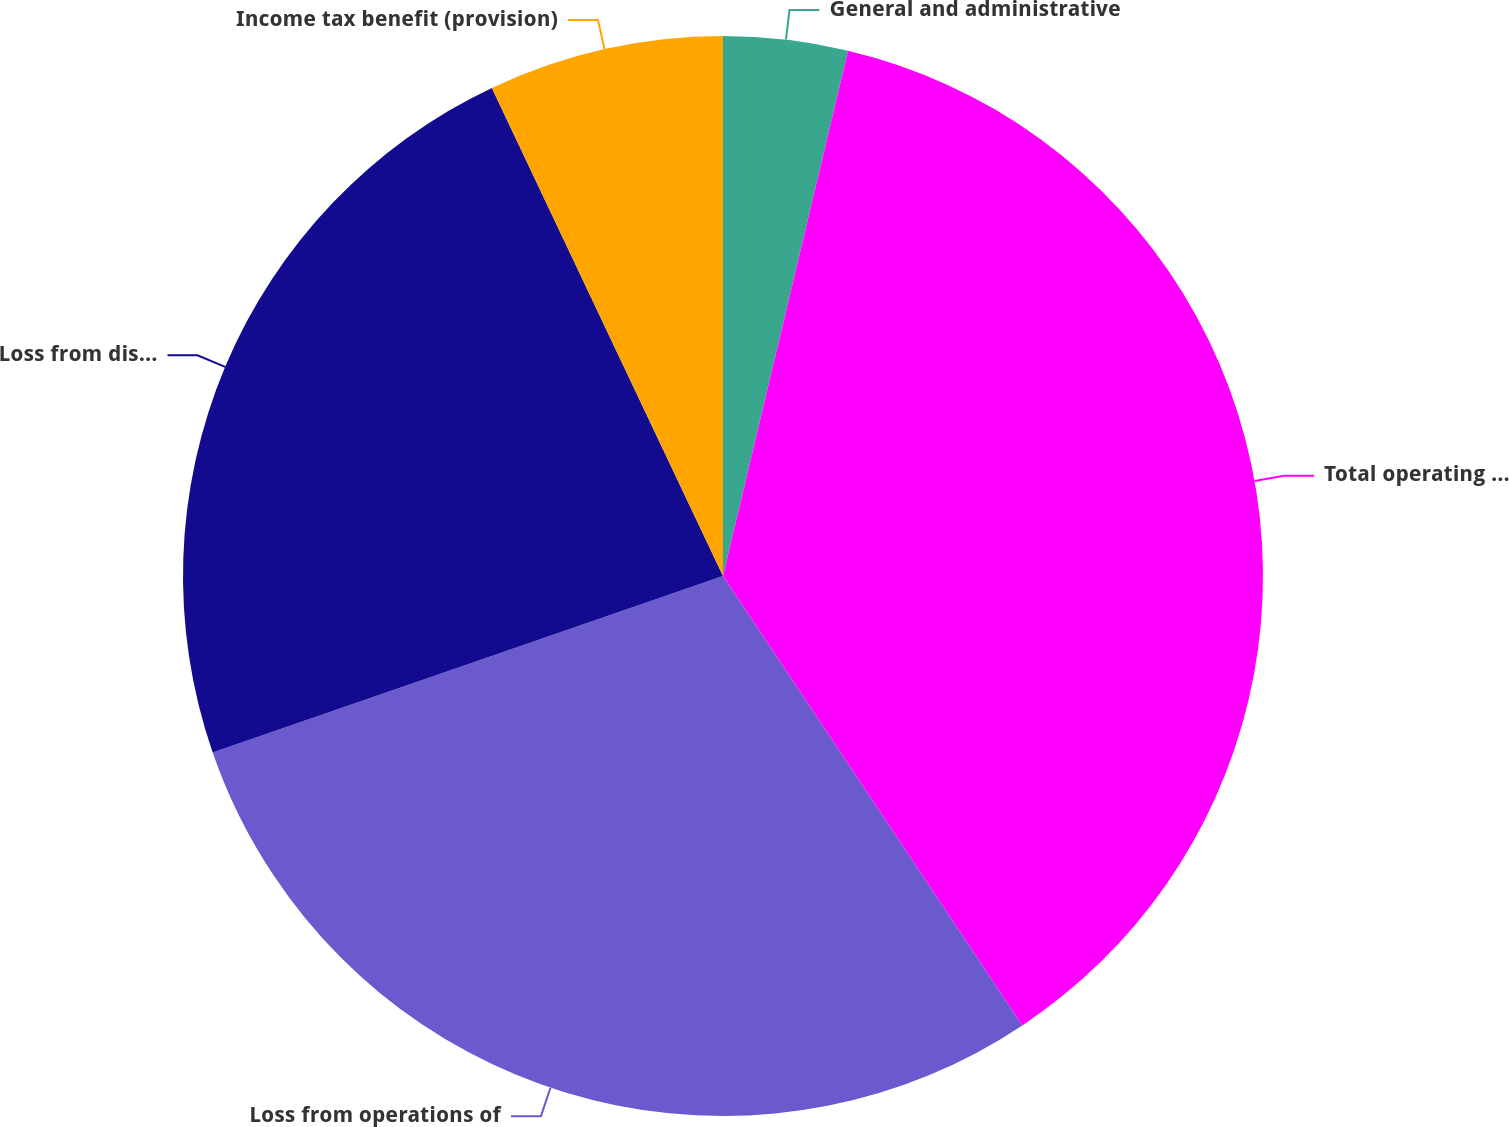Convert chart to OTSL. <chart><loc_0><loc_0><loc_500><loc_500><pie_chart><fcel>General and administrative<fcel>Total operating expenses<fcel>Loss from operations of<fcel>Loss from discontinued<fcel>Income tax benefit (provision)<nl><fcel>3.72%<fcel>36.93%<fcel>29.05%<fcel>23.26%<fcel>7.04%<nl></chart> 